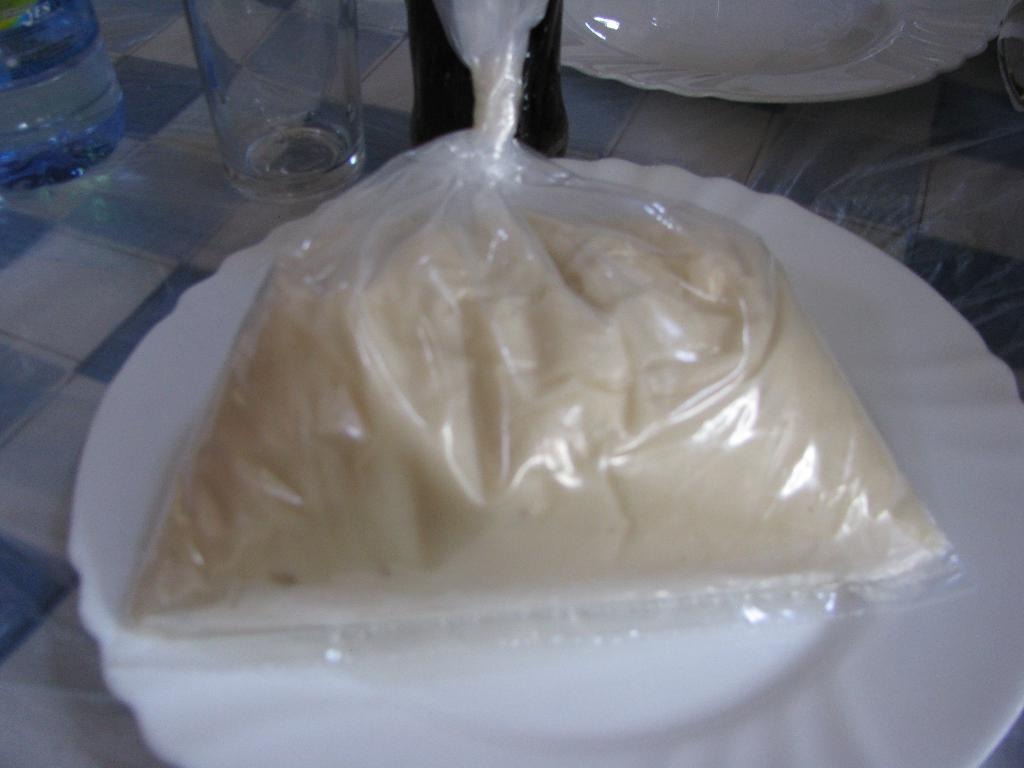What piece of furniture is present in the image? There is a table in the image. What is placed on the table? There is a glass, a water bottle, a cool drink bottle, and 2 plates on the table. What is on the plates? There is a packet of some food item on the plates. Can you see a zipper on the food item packets? There is no mention of a zipper on the food item packets in the image. Is there a receipt for the items on the table? There is no receipt visible in the image. 